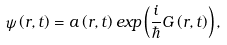<formula> <loc_0><loc_0><loc_500><loc_500>\psi \left ( { r } , t \right ) = a \left ( { r } , t \right ) e x p \left ( \frac { i } { \hbar } { G } \left ( { r } , t \right ) \right ) ,</formula> 